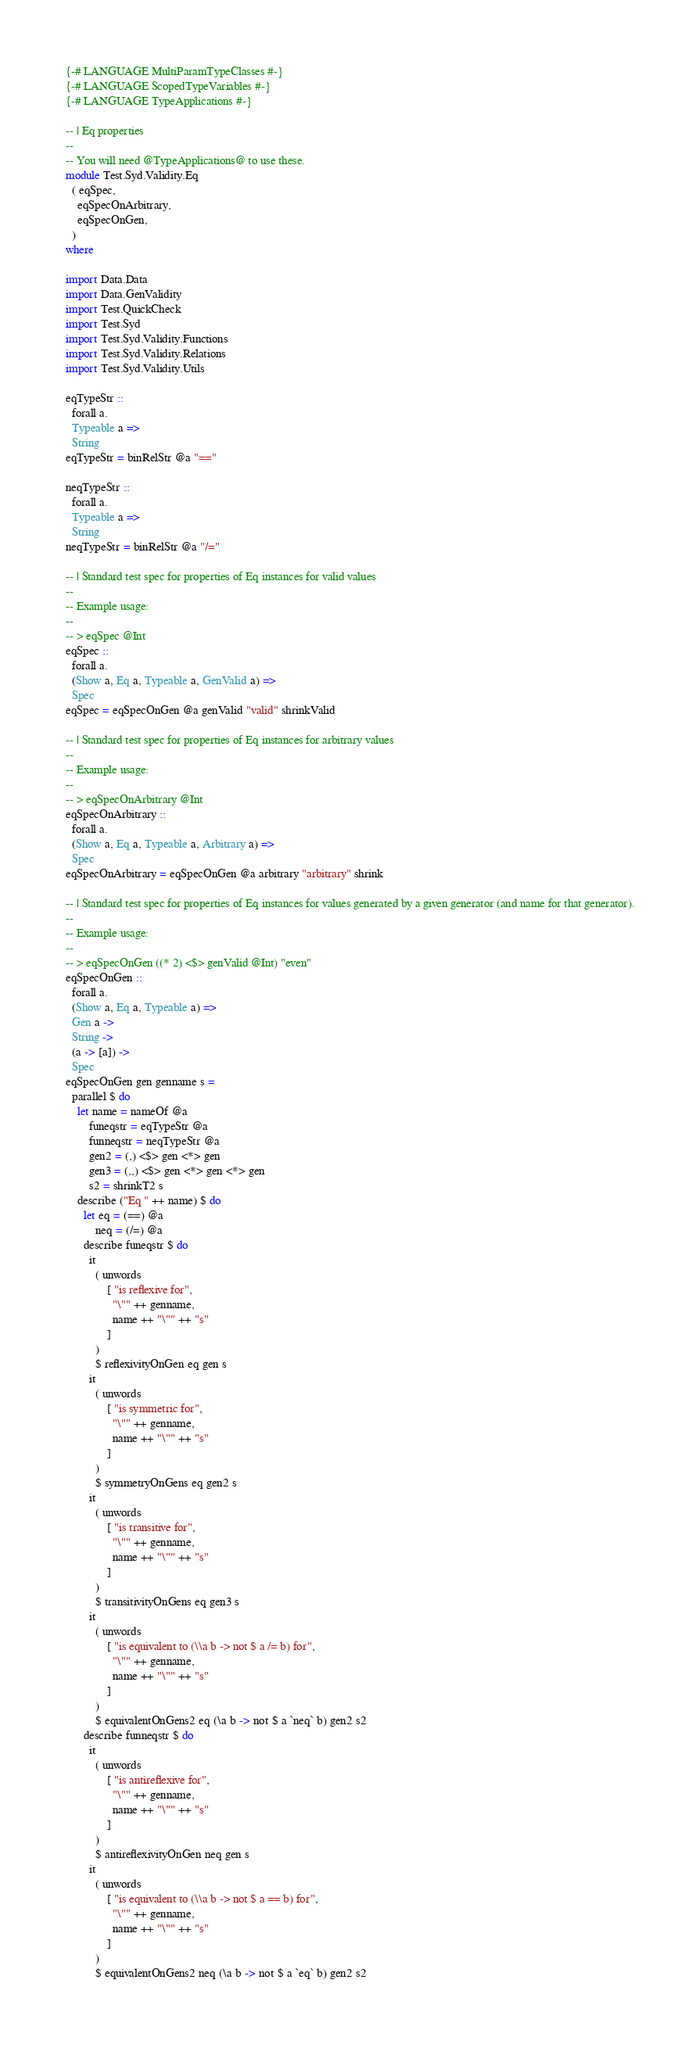<code> <loc_0><loc_0><loc_500><loc_500><_Haskell_>{-# LANGUAGE MultiParamTypeClasses #-}
{-# LANGUAGE ScopedTypeVariables #-}
{-# LANGUAGE TypeApplications #-}

-- | Eq properties
--
-- You will need @TypeApplications@ to use these.
module Test.Syd.Validity.Eq
  ( eqSpec,
    eqSpecOnArbitrary,
    eqSpecOnGen,
  )
where

import Data.Data
import Data.GenValidity
import Test.QuickCheck
import Test.Syd
import Test.Syd.Validity.Functions
import Test.Syd.Validity.Relations
import Test.Syd.Validity.Utils

eqTypeStr ::
  forall a.
  Typeable a =>
  String
eqTypeStr = binRelStr @a "=="

neqTypeStr ::
  forall a.
  Typeable a =>
  String
neqTypeStr = binRelStr @a "/="

-- | Standard test spec for properties of Eq instances for valid values
--
-- Example usage:
--
-- > eqSpec @Int
eqSpec ::
  forall a.
  (Show a, Eq a, Typeable a, GenValid a) =>
  Spec
eqSpec = eqSpecOnGen @a genValid "valid" shrinkValid

-- | Standard test spec for properties of Eq instances for arbitrary values
--
-- Example usage:
--
-- > eqSpecOnArbitrary @Int
eqSpecOnArbitrary ::
  forall a.
  (Show a, Eq a, Typeable a, Arbitrary a) =>
  Spec
eqSpecOnArbitrary = eqSpecOnGen @a arbitrary "arbitrary" shrink

-- | Standard test spec for properties of Eq instances for values generated by a given generator (and name for that generator).
--
-- Example usage:
--
-- > eqSpecOnGen ((* 2) <$> genValid @Int) "even"
eqSpecOnGen ::
  forall a.
  (Show a, Eq a, Typeable a) =>
  Gen a ->
  String ->
  (a -> [a]) ->
  Spec
eqSpecOnGen gen genname s =
  parallel $ do
    let name = nameOf @a
        funeqstr = eqTypeStr @a
        funneqstr = neqTypeStr @a
        gen2 = (,) <$> gen <*> gen
        gen3 = (,,) <$> gen <*> gen <*> gen
        s2 = shrinkT2 s
    describe ("Eq " ++ name) $ do
      let eq = (==) @a
          neq = (/=) @a
      describe funeqstr $ do
        it
          ( unwords
              [ "is reflexive for",
                "\"" ++ genname,
                name ++ "\"" ++ "s"
              ]
          )
          $ reflexivityOnGen eq gen s
        it
          ( unwords
              [ "is symmetric for",
                "\"" ++ genname,
                name ++ "\"" ++ "s"
              ]
          )
          $ symmetryOnGens eq gen2 s
        it
          ( unwords
              [ "is transitive for",
                "\"" ++ genname,
                name ++ "\"" ++ "s"
              ]
          )
          $ transitivityOnGens eq gen3 s
        it
          ( unwords
              [ "is equivalent to (\\a b -> not $ a /= b) for",
                "\"" ++ genname,
                name ++ "\"" ++ "s"
              ]
          )
          $ equivalentOnGens2 eq (\a b -> not $ a `neq` b) gen2 s2
      describe funneqstr $ do
        it
          ( unwords
              [ "is antireflexive for",
                "\"" ++ genname,
                name ++ "\"" ++ "s"
              ]
          )
          $ antireflexivityOnGen neq gen s
        it
          ( unwords
              [ "is equivalent to (\\a b -> not $ a == b) for",
                "\"" ++ genname,
                name ++ "\"" ++ "s"
              ]
          )
          $ equivalentOnGens2 neq (\a b -> not $ a `eq` b) gen2 s2
</code> 